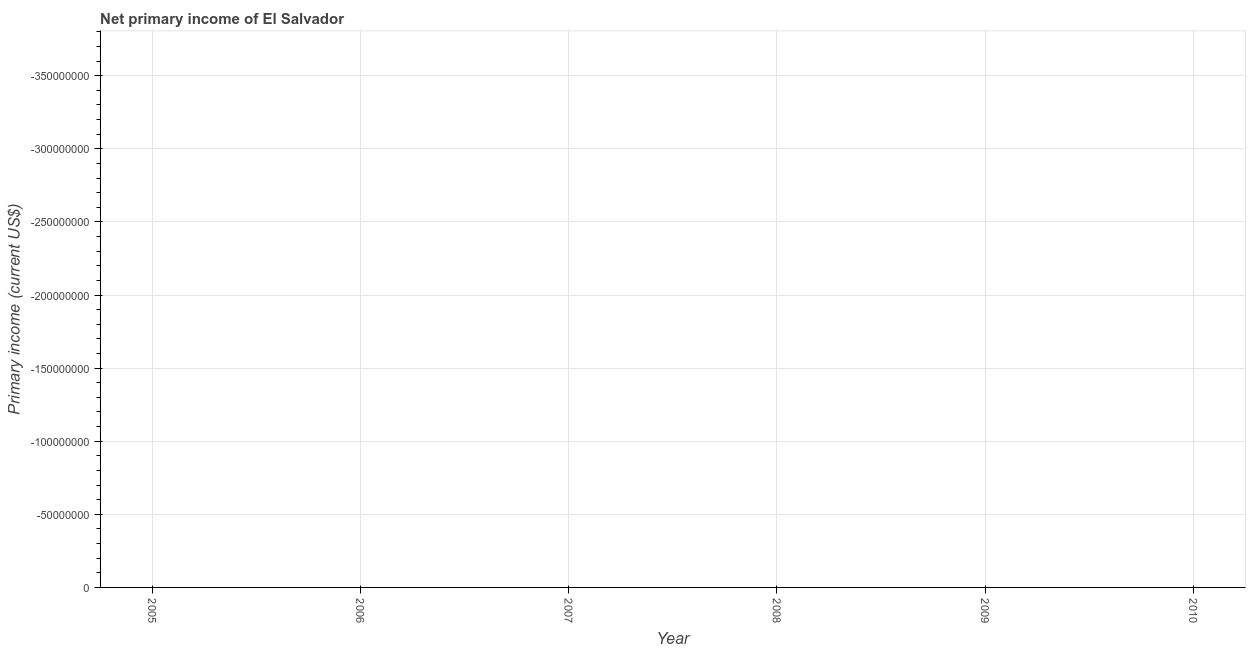What is the amount of primary income in 2009?
Your response must be concise. 0. What is the average amount of primary income per year?
Your response must be concise. 0. In how many years, is the amount of primary income greater than -80000000 US$?
Offer a very short reply. 0. In how many years, is the amount of primary income greater than the average amount of primary income taken over all years?
Make the answer very short. 0. What is the difference between two consecutive major ticks on the Y-axis?
Offer a terse response. 5.00e+07. Are the values on the major ticks of Y-axis written in scientific E-notation?
Ensure brevity in your answer.  No. What is the title of the graph?
Offer a very short reply. Net primary income of El Salvador. What is the label or title of the X-axis?
Give a very brief answer. Year. What is the label or title of the Y-axis?
Offer a terse response. Primary income (current US$). What is the Primary income (current US$) of 2005?
Offer a very short reply. 0. What is the Primary income (current US$) of 2007?
Give a very brief answer. 0. What is the Primary income (current US$) of 2008?
Your answer should be compact. 0. 